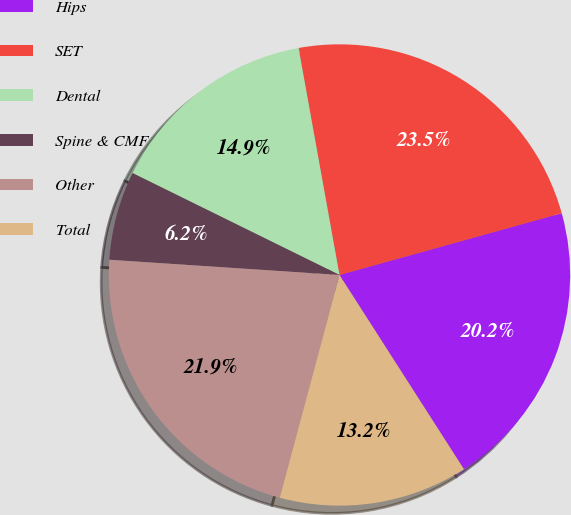Convert chart to OTSL. <chart><loc_0><loc_0><loc_500><loc_500><pie_chart><fcel>Hips<fcel>SET<fcel>Dental<fcel>Spine & CMF<fcel>Other<fcel>Total<nl><fcel>20.25%<fcel>23.52%<fcel>14.88%<fcel>6.23%<fcel>21.88%<fcel>13.24%<nl></chart> 